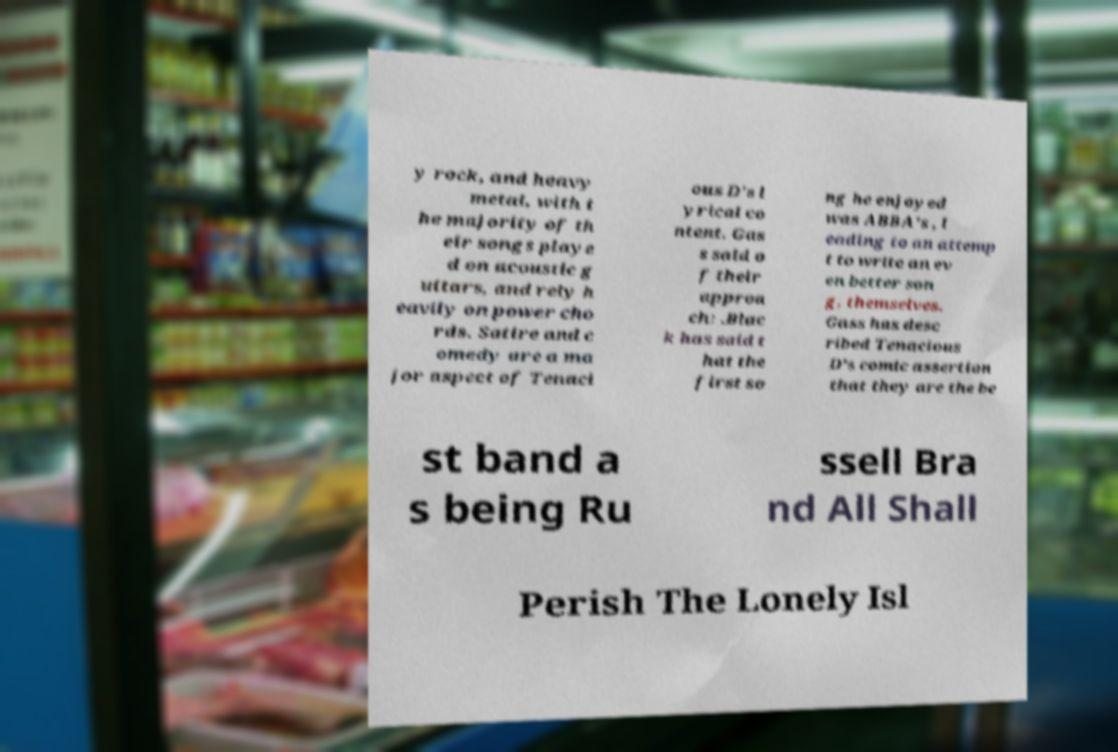Can you read and provide the text displayed in the image?This photo seems to have some interesting text. Can you extract and type it out for me? y rock, and heavy metal, with t he majority of th eir songs playe d on acoustic g uitars, and rely h eavily on power cho rds. Satire and c omedy are a ma jor aspect of Tenaci ous D's l yrical co ntent. Gas s said o f their approa ch: .Blac k has said t hat the first so ng he enjoyed was ABBA's , l eading to an attemp t to write an ev en better son g, themselves. Gass has desc ribed Tenacious D's comic assertion that they are the be st band a s being Ru ssell Bra nd All Shall Perish The Lonely Isl 